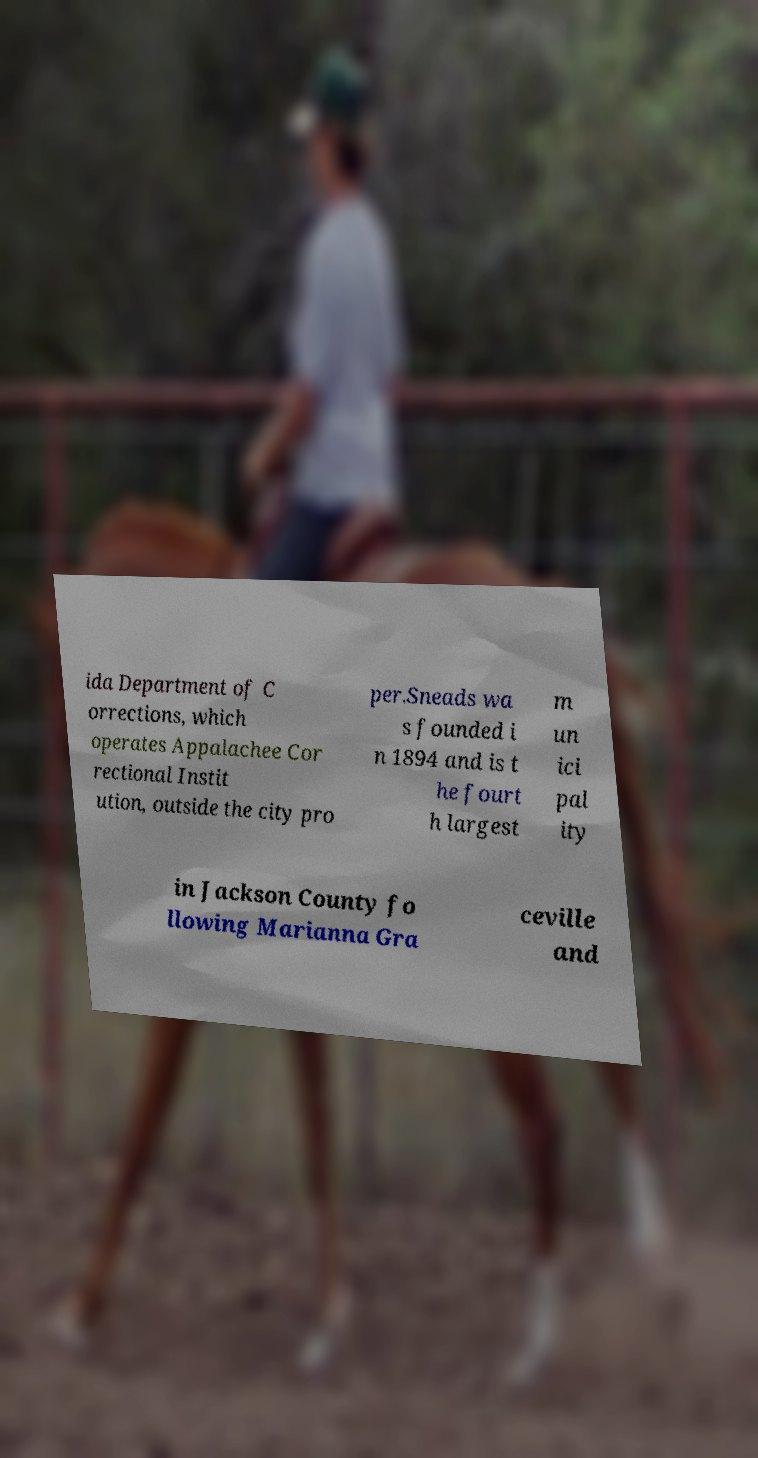Could you assist in decoding the text presented in this image and type it out clearly? ida Department of C orrections, which operates Appalachee Cor rectional Instit ution, outside the city pro per.Sneads wa s founded i n 1894 and is t he fourt h largest m un ici pal ity in Jackson County fo llowing Marianna Gra ceville and 